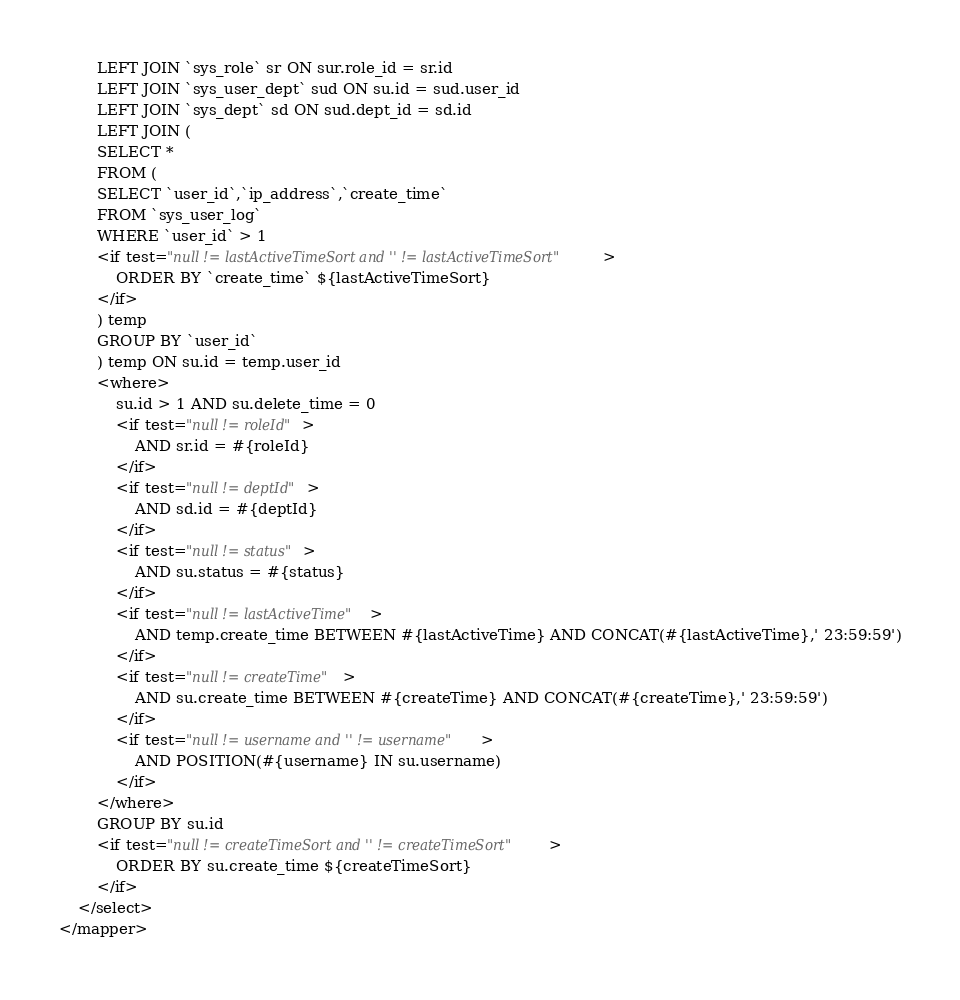Convert code to text. <code><loc_0><loc_0><loc_500><loc_500><_XML_>        LEFT JOIN `sys_role` sr ON sur.role_id = sr.id
        LEFT JOIN `sys_user_dept` sud ON su.id = sud.user_id
        LEFT JOIN `sys_dept` sd ON sud.dept_id = sd.id
        LEFT JOIN (
        SELECT *
        FROM (
        SELECT `user_id`,`ip_address`,`create_time`
        FROM `sys_user_log`
        WHERE `user_id` > 1
        <if test="null != lastActiveTimeSort and '' != lastActiveTimeSort">
            ORDER BY `create_time` ${lastActiveTimeSort}
        </if>
        ) temp
        GROUP BY `user_id`
        ) temp ON su.id = temp.user_id
        <where>
            su.id > 1 AND su.delete_time = 0
            <if test="null != roleId">
                AND sr.id = #{roleId}
            </if>
            <if test="null != deptId">
                AND sd.id = #{deptId}
            </if>
            <if test="null != status">
                AND su.status = #{status}
            </if>
            <if test="null != lastActiveTime">
                AND temp.create_time BETWEEN #{lastActiveTime} AND CONCAT(#{lastActiveTime},' 23:59:59')
            </if>
            <if test="null != createTime">
                AND su.create_time BETWEEN #{createTime} AND CONCAT(#{createTime},' 23:59:59')
            </if>
            <if test="null != username and '' != username">
                AND POSITION(#{username} IN su.username)
            </if>
        </where>
        GROUP BY su.id
        <if test="null != createTimeSort and '' != createTimeSort">
            ORDER BY su.create_time ${createTimeSort}
        </if>
    </select>
</mapper></code> 